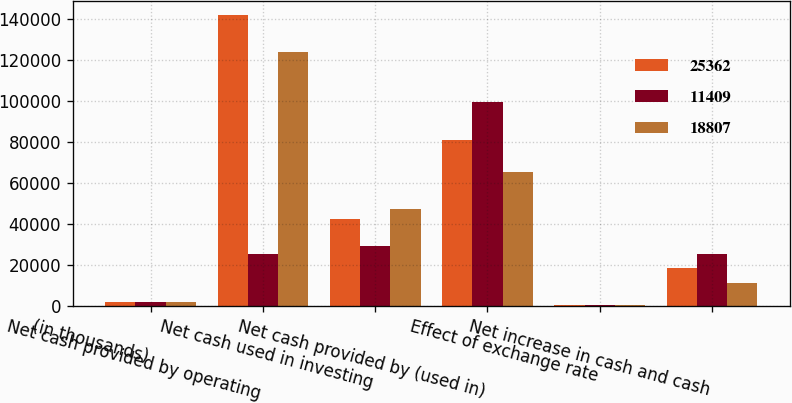Convert chart to OTSL. <chart><loc_0><loc_0><loc_500><loc_500><stacked_bar_chart><ecel><fcel>(in thousands)<fcel>Net cash provided by operating<fcel>Net cash used in investing<fcel>Net cash provided by (used in)<fcel>Effect of exchange rate<fcel>Net increase in cash and cash<nl><fcel>25362<fcel>2012<fcel>141919<fcel>42693<fcel>80989<fcel>570<fcel>18807<nl><fcel>11409<fcel>2011<fcel>25362<fcel>29154<fcel>99427<fcel>704<fcel>25362<nl><fcel>18807<fcel>2010<fcel>124053<fcel>47645<fcel>65497<fcel>498<fcel>11409<nl></chart> 